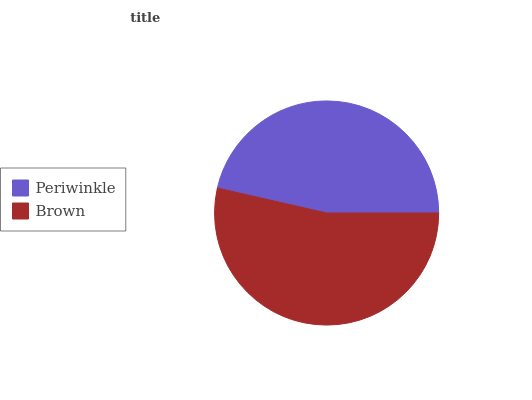Is Periwinkle the minimum?
Answer yes or no. Yes. Is Brown the maximum?
Answer yes or no. Yes. Is Brown the minimum?
Answer yes or no. No. Is Brown greater than Periwinkle?
Answer yes or no. Yes. Is Periwinkle less than Brown?
Answer yes or no. Yes. Is Periwinkle greater than Brown?
Answer yes or no. No. Is Brown less than Periwinkle?
Answer yes or no. No. Is Brown the high median?
Answer yes or no. Yes. Is Periwinkle the low median?
Answer yes or no. Yes. Is Periwinkle the high median?
Answer yes or no. No. Is Brown the low median?
Answer yes or no. No. 